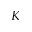<formula> <loc_0><loc_0><loc_500><loc_500>K</formula> 